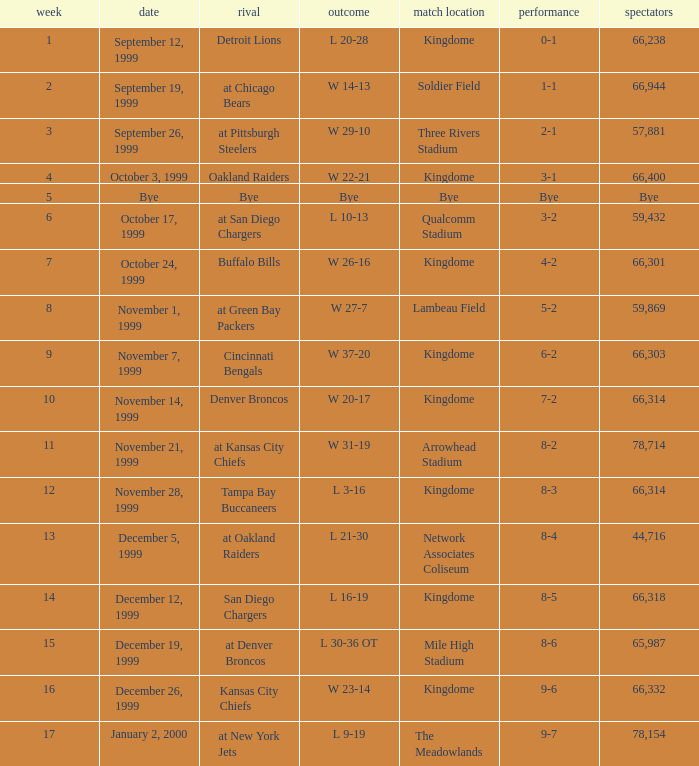Could you parse the entire table? {'header': ['week', 'date', 'rival', 'outcome', 'match location', 'performance', 'spectators'], 'rows': [['1', 'September 12, 1999', 'Detroit Lions', 'L 20-28', 'Kingdome', '0-1', '66,238'], ['2', 'September 19, 1999', 'at Chicago Bears', 'W 14-13', 'Soldier Field', '1-1', '66,944'], ['3', 'September 26, 1999', 'at Pittsburgh Steelers', 'W 29-10', 'Three Rivers Stadium', '2-1', '57,881'], ['4', 'October 3, 1999', 'Oakland Raiders', 'W 22-21', 'Kingdome', '3-1', '66,400'], ['5', 'Bye', 'Bye', 'Bye', 'Bye', 'Bye', 'Bye'], ['6', 'October 17, 1999', 'at San Diego Chargers', 'L 10-13', 'Qualcomm Stadium', '3-2', '59,432'], ['7', 'October 24, 1999', 'Buffalo Bills', 'W 26-16', 'Kingdome', '4-2', '66,301'], ['8', 'November 1, 1999', 'at Green Bay Packers', 'W 27-7', 'Lambeau Field', '5-2', '59,869'], ['9', 'November 7, 1999', 'Cincinnati Bengals', 'W 37-20', 'Kingdome', '6-2', '66,303'], ['10', 'November 14, 1999', 'Denver Broncos', 'W 20-17', 'Kingdome', '7-2', '66,314'], ['11', 'November 21, 1999', 'at Kansas City Chiefs', 'W 31-19', 'Arrowhead Stadium', '8-2', '78,714'], ['12', 'November 28, 1999', 'Tampa Bay Buccaneers', 'L 3-16', 'Kingdome', '8-3', '66,314'], ['13', 'December 5, 1999', 'at Oakland Raiders', 'L 21-30', 'Network Associates Coliseum', '8-4', '44,716'], ['14', 'December 12, 1999', 'San Diego Chargers', 'L 16-19', 'Kingdome', '8-5', '66,318'], ['15', 'December 19, 1999', 'at Denver Broncos', 'L 30-36 OT', 'Mile High Stadium', '8-6', '65,987'], ['16', 'December 26, 1999', 'Kansas City Chiefs', 'W 23-14', 'Kingdome', '9-6', '66,332'], ['17', 'January 2, 2000', 'at New York Jets', 'L 9-19', 'The Meadowlands', '9-7', '78,154']]} What was the result of the game that was played on week 15? L 30-36 OT. 